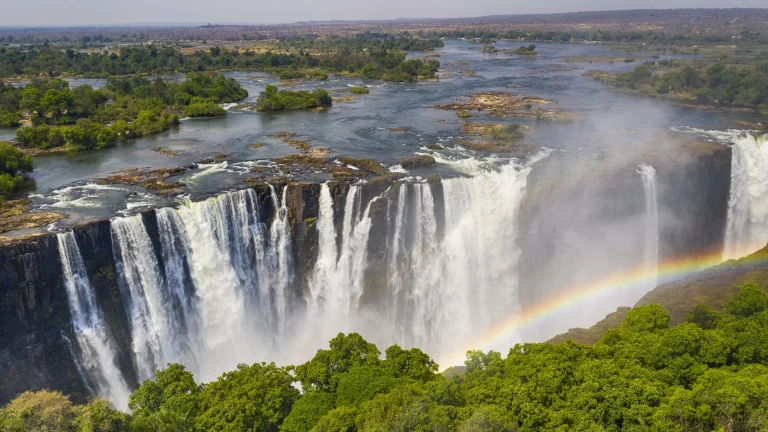Can you tell me more about the history of this waterfall? Victoria Falls, known locally as Mosi-oa-Tunya which translates to 'The Smoke That Thunders,' has a rich history intertwined with exploration and indigenous culture. The falls were first brought to international attention in 1855 by the Scottish missionary and explorer David Livingstone, who named them in honor of Queen Victoria of Britain. However, long before Livingstone's arrival, the site was revered by the local Kololo tribe for its sheer power and mystique. Over the years, Victoria Falls has become a significant tourism hub, renowned for both its unparalleled natural beauty and adventure activities such as whitewater rafting, bungee jumping, and helicopter tours. Additionally, the falls are an essential cultural and spiritual symbol for the local communities, recognized as a UNESCO World Heritage Site in 1989, ensuring its preservation for future generations. How have local communities adapted to living near such a powerful natural feature? Living near Victoria Falls, local communities have historically adapted by incorporating the waterfall into many aspects of life. Economically, the falls have spurred local tourism businesses, ranging from guiding services to artisanal crafts. Ecologically, the communities have developed sustainable fishing and agriculture practices that respect the surrounding environment. Culturally, the falls hold significant spiritual value, featuring prominently in local folklore and rituals. Additionally, modern efforts have focused on balancing environmental conservation with economic benefits, ensuring that the surrounding ecosystem and the way of life for the local people are protected and sustained. If I visit Victoria Falls, what other attractions or activities could I explore nearby? Aside from the mesmerizing view of Victoria Falls, there are numerous activities and attractions to explore in the vicinity. For thrill-seekers, there's bungee jumping off the Victoria Falls Bridge, river rafting in the rapids of the Zambezi, and zip-lining across the gorge. For wildlife enthusiasts, there's Zambezi National Park, where you can embark on safaris to see elephants, lions, and other African wildlife in their natural habitat. Cultural experiences include visiting local villages to learn about their traditions and crafts. Additionally, scenic flights or helicopter rides over the falls provide a bird's-eye view of this natural wonder, offering a unique perspective that highlights its majestic scale. The Victoria Falls area is rich with diverse adventures that cater to a wide range of interests. Imagine the waterfall is a portal to another dimension. What kind of world would you find behind it? Imagine stepping through the thundering cascade of Victoria Falls, entering a portal to an otherworldly dimension. Behind the waterfall, you'd emerge in a realm of ethereal beauty and mystic energies. Vast, bioluminescent forests encircle crystal-clear lakes that mirror the radiant sky, filled with floating islands that defy gravity. The air is alive with the songs of creatures unseen in our world, carrying the harmonious hum of an unfamiliar yet enchanting language. Waterfalls in this dimension flow upwards, seemingly originating from the ground and ascending into the sky, merging into spheres of pure, glowing water. Plants and trees possess a semi-sentient presence, gracefully dancing as if in communication with each other. Amidst this surreal landscape, ancient structures crafted from shimmering materials stand as monuments to an advanced and harmonious civilization. It's a world where the boundaries between nature, magic, and technology blur, presenting an existence where the wildest fantasies are the everyday reality. 